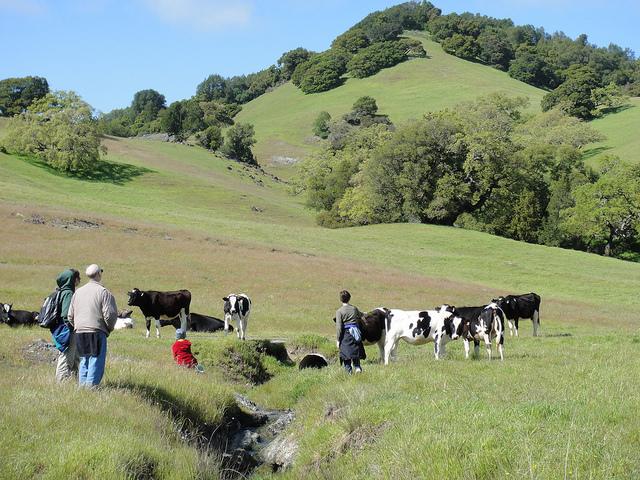Are the cows all facing the same direction?
Write a very short answer. No. Are all the trees green?
Concise answer only. Yes. What is this group of livestock called?
Write a very short answer. Cows. Would a vegetarian eat this animal?
Answer briefly. No. How many animals are shown?
Be succinct. 7. What animals are these?
Short answer required. Cows. How many cows and people?
Give a very brief answer. 12. What color is the bigger animal?
Concise answer only. Black. 